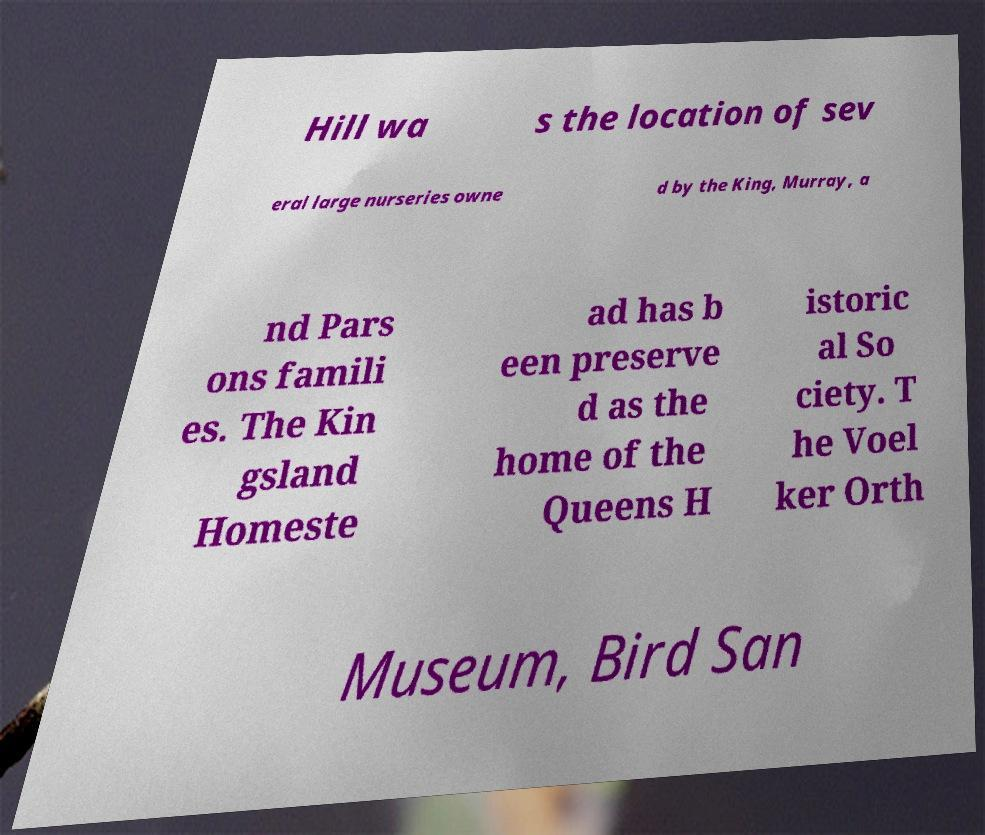There's text embedded in this image that I need extracted. Can you transcribe it verbatim? Hill wa s the location of sev eral large nurseries owne d by the King, Murray, a nd Pars ons famili es. The Kin gsland Homeste ad has b een preserve d as the home of the Queens H istoric al So ciety. T he Voel ker Orth Museum, Bird San 